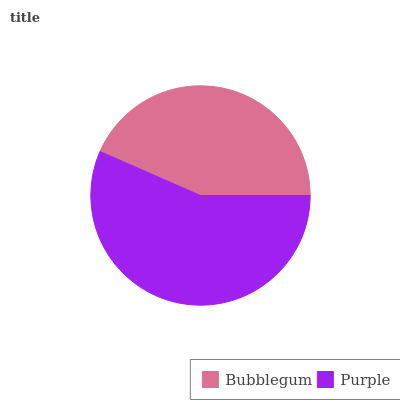Is Bubblegum the minimum?
Answer yes or no. Yes. Is Purple the maximum?
Answer yes or no. Yes. Is Purple the minimum?
Answer yes or no. No. Is Purple greater than Bubblegum?
Answer yes or no. Yes. Is Bubblegum less than Purple?
Answer yes or no. Yes. Is Bubblegum greater than Purple?
Answer yes or no. No. Is Purple less than Bubblegum?
Answer yes or no. No. Is Purple the high median?
Answer yes or no. Yes. Is Bubblegum the low median?
Answer yes or no. Yes. Is Bubblegum the high median?
Answer yes or no. No. Is Purple the low median?
Answer yes or no. No. 